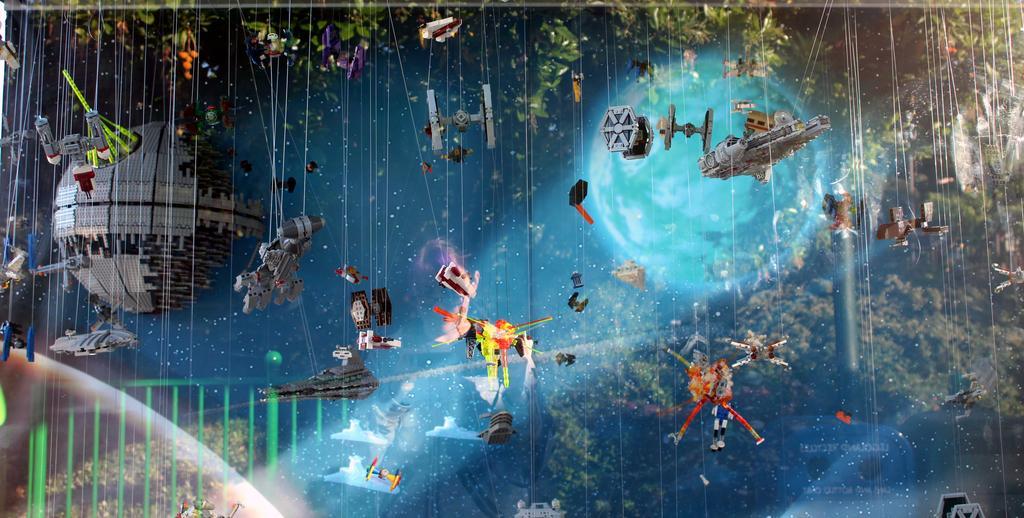In one or two sentences, can you explain what this image depicts? In this image we can see toys and objects tied to the threads and are hanging in the air. In the background we can see globes, objects and trees. 